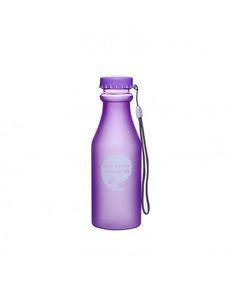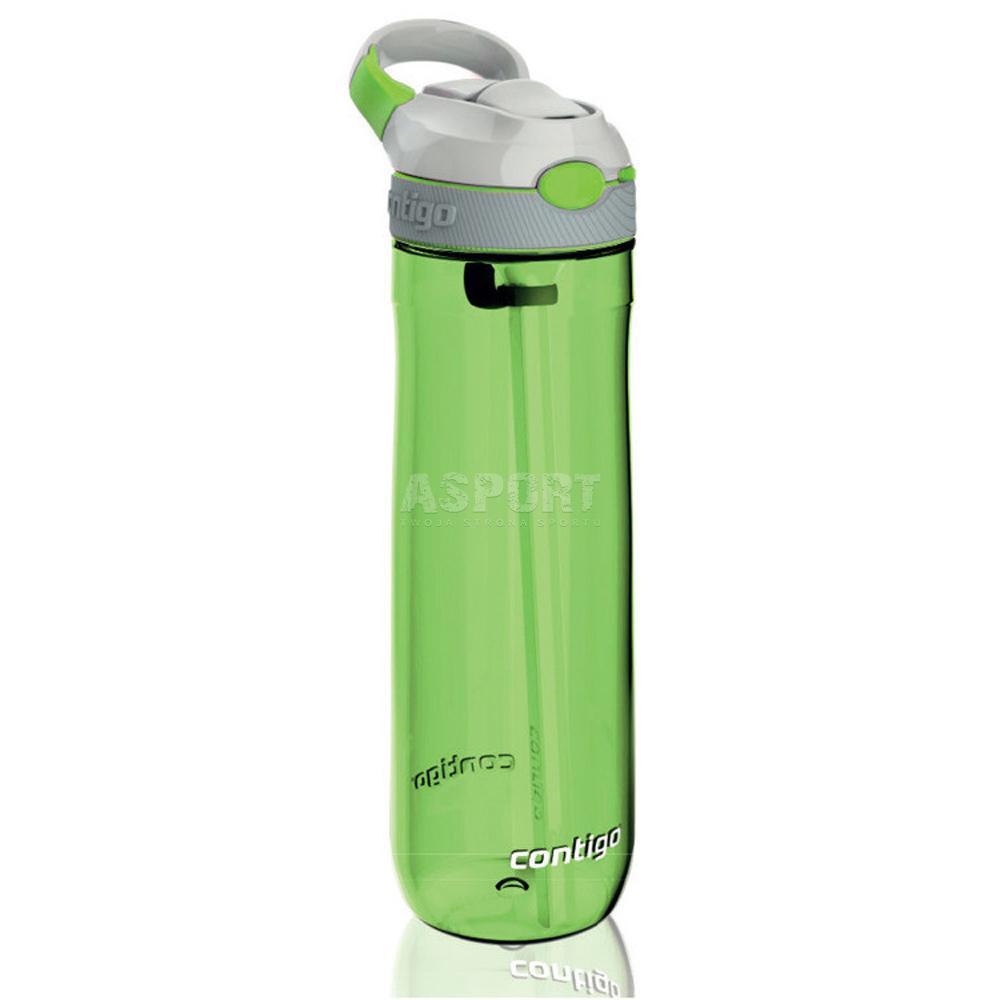The first image is the image on the left, the second image is the image on the right. For the images shown, is this caption "At least one water bottle has a carrying strap hanging loosely down the side." true? Answer yes or no. Yes. 